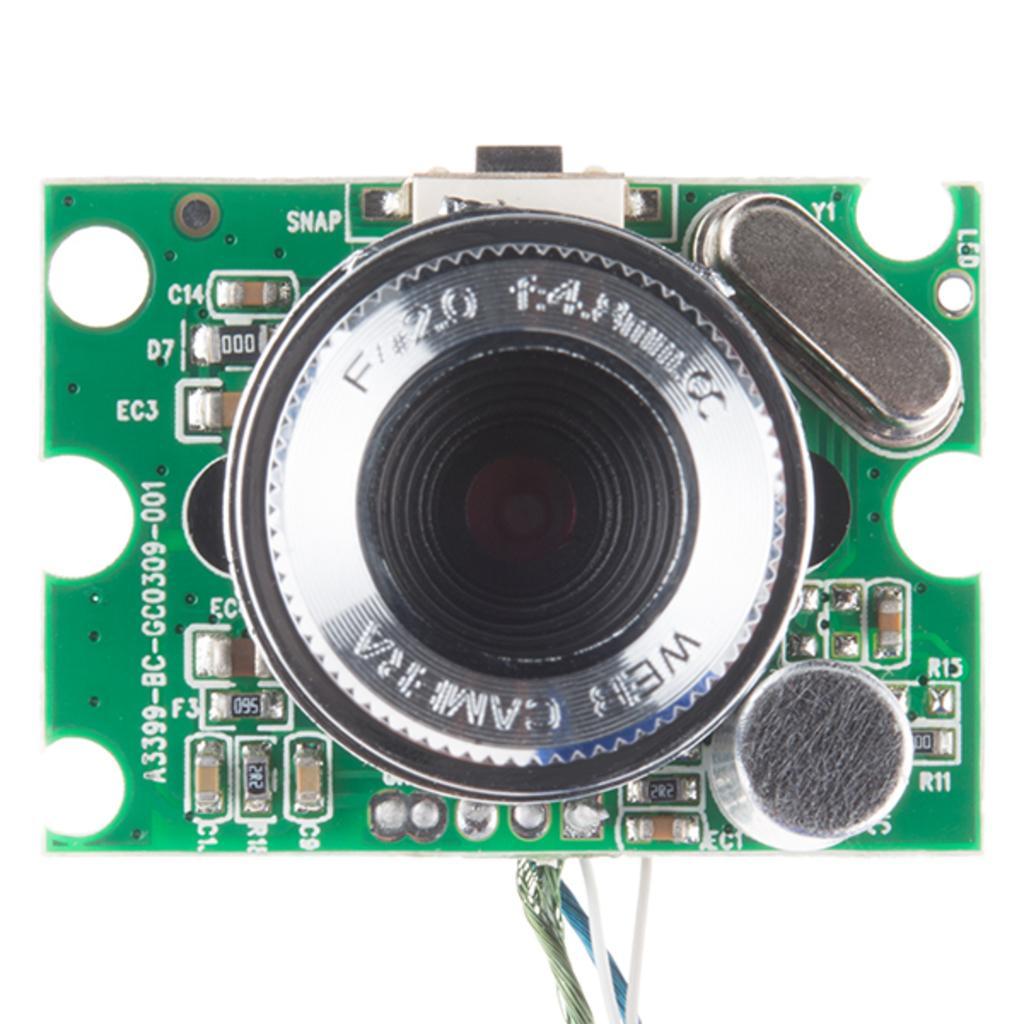Please provide a concise description of this image. In this image, we can see a chip which is in green color. Here we can see something is written on it. At the bottom, there are few wires. 